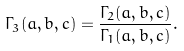<formula> <loc_0><loc_0><loc_500><loc_500>\Gamma _ { 3 } ( a , b , c ) = \frac { \Gamma _ { 2 } ( a , b , c ) } { \Gamma _ { 1 } ( a , b , c ) } .</formula> 